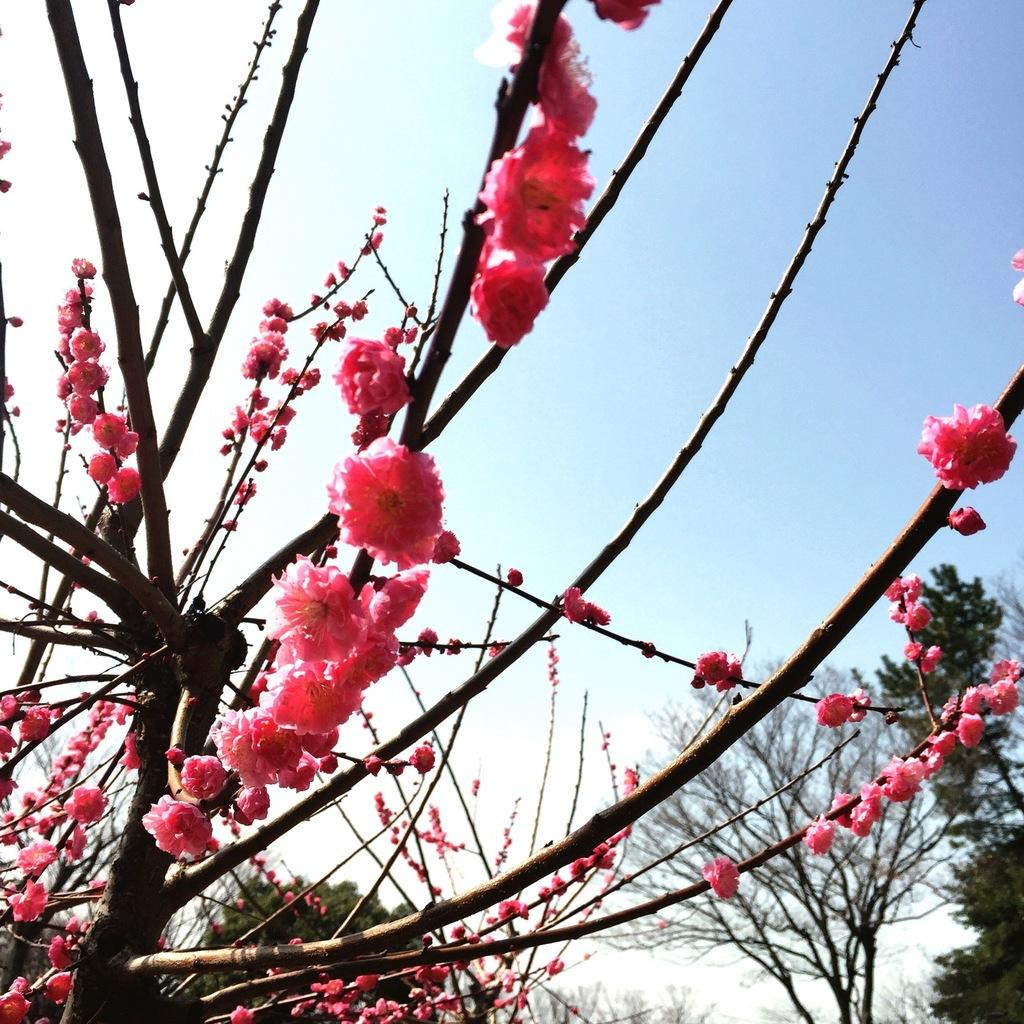What color are the flowers on the trees in the image? The flowers on the trees are pink in color. What can be seen in the background of the image? The sky and trees are visible in the background of the image. Can you touch the wine in the image? There is no wine present in the image, so it cannot be touched. 